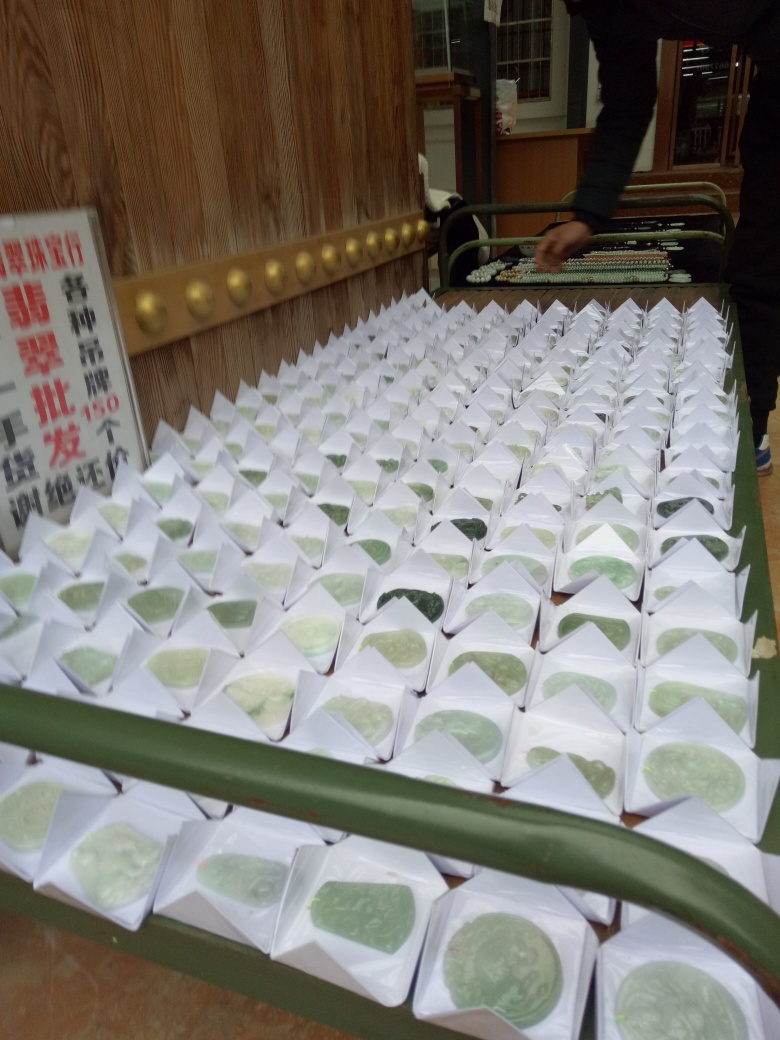Can you tell something about the location or event where this photo is taken? The setting of the photo, based on the background elements like the wooden wall and decorated balusters, as well as the uniform, mass arrangement of the items, suggests that this might be a special event or market place in an East Asian locale, possibly related to a cultural or festive sale. 